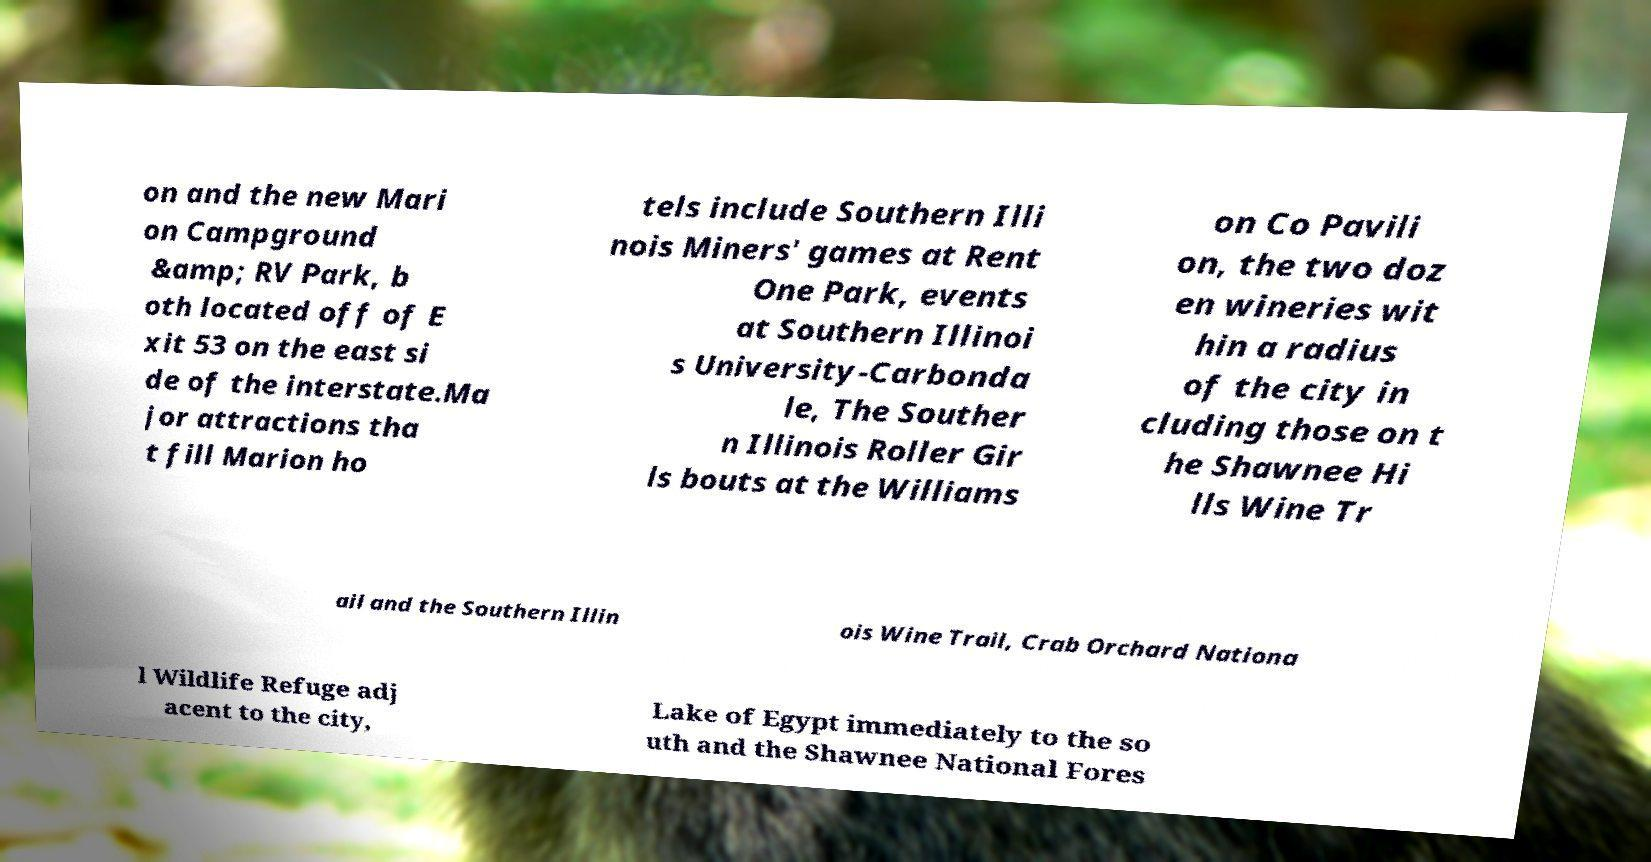Could you extract and type out the text from this image? on and the new Mari on Campground &amp; RV Park, b oth located off of E xit 53 on the east si de of the interstate.Ma jor attractions tha t fill Marion ho tels include Southern Illi nois Miners' games at Rent One Park, events at Southern Illinoi s University-Carbonda le, The Souther n Illinois Roller Gir ls bouts at the Williams on Co Pavili on, the two doz en wineries wit hin a radius of the city in cluding those on t he Shawnee Hi lls Wine Tr ail and the Southern Illin ois Wine Trail, Crab Orchard Nationa l Wildlife Refuge adj acent to the city, Lake of Egypt immediately to the so uth and the Shawnee National Fores 